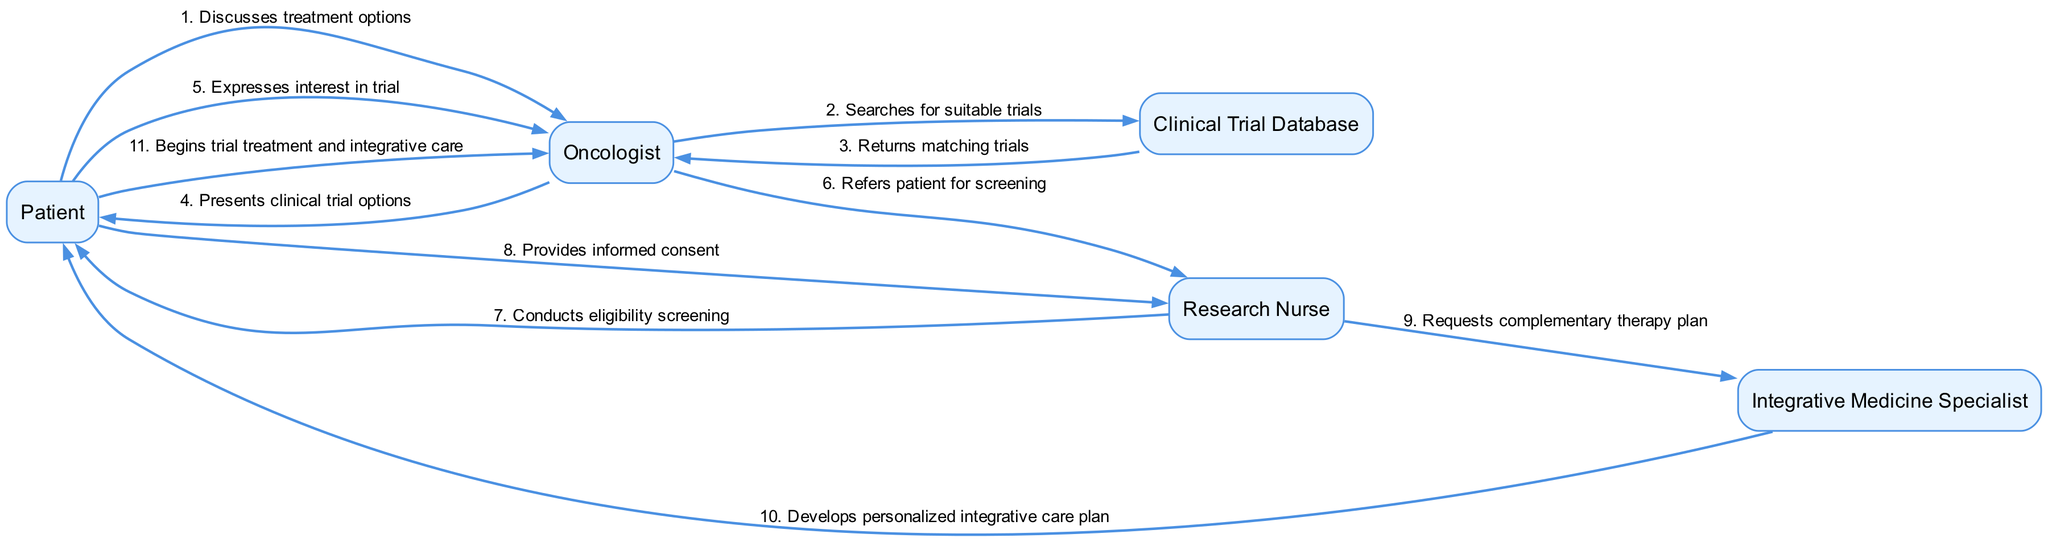What is the first action between the Patient and Oncologist? The diagram shows that the first action is the Patient discussing treatment options with the Oncologist. This is the first message exchanged in the sequence.
Answer: Discusses treatment options How many actors are involved in this sequence diagram? The diagram includes five distinct actors: Patient, Oncologist, Research Nurse, Integrative Medicine Specialist, and Clinical Trial Database. Counting these gives us the total number of actors.
Answer: Five What is the last step in the patient journey? The last step in the sequence indicates that the Patient begins trial treatment and integrative care. This is the completion of the process represented in the diagram.
Answer: Begins trial treatment and integrative care Which actor requests a complementary therapy plan? The Research Nurse is responsible for requesting the complementary therapy plan from the Integrative Medicine Specialist. This message indicates their collaboration for the patient's care.
Answer: Research Nurse How does the Oncologist respond after finding suitable trials? After searching the Clinical Trial Database for suitable trials, the Oncologist presents the clinical trial options to the Patient. This shows the flow of information from the database to the oncologist and then to the patient.
Answer: Presents clinical trial options What does the Integrative Medicine Specialist provide to the Patient? The Integrative Medicine Specialist develops a personalized integrative care plan for the Patient. This is a specific action reflecting the focus on integrative medicine in the patient's journey.
Answer: Develops personalized integrative care plan What step follows after the Patient expresses interest in the trial? Following the Patient's expression of interest in the trial, the Oncologist refers the Patient for screening, which is necessary for determining eligibility for the clinical trial.
Answer: Refers patient for screening Which actor conducts eligibility screening? The Research Nurse is the actor responsible for conducting the eligibility screening of the Patient. This shows their role in assessing whether the Patient meets the criteria for the clinical trial.
Answer: Research Nurse 